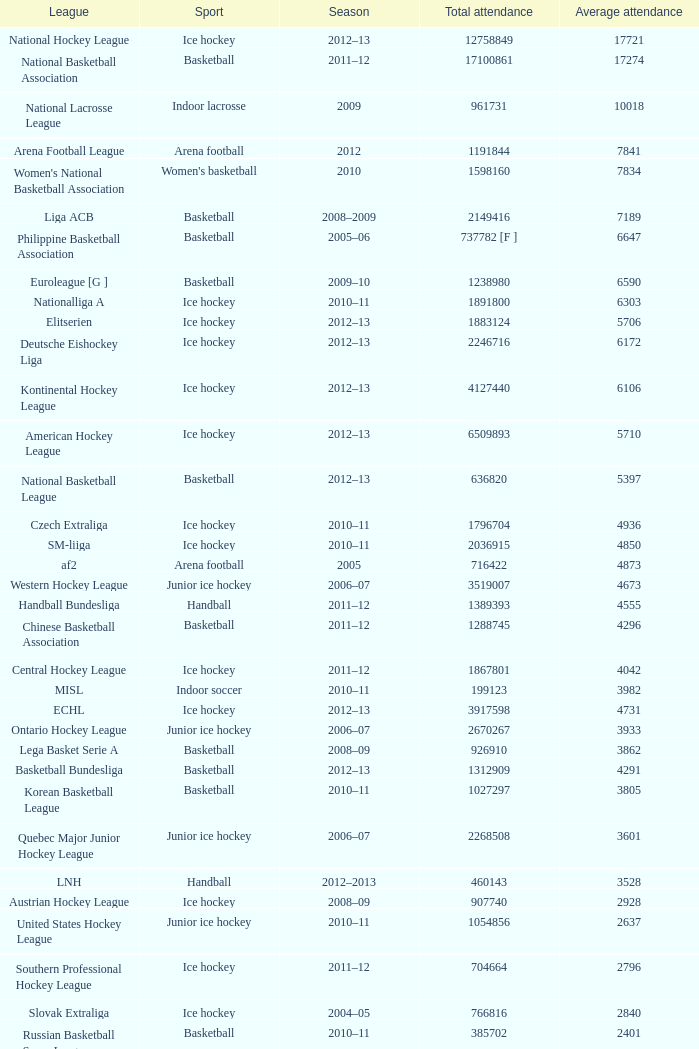What's the total attendance in rink hockey when the average attendance was smaller than 4850? 115000.0. 